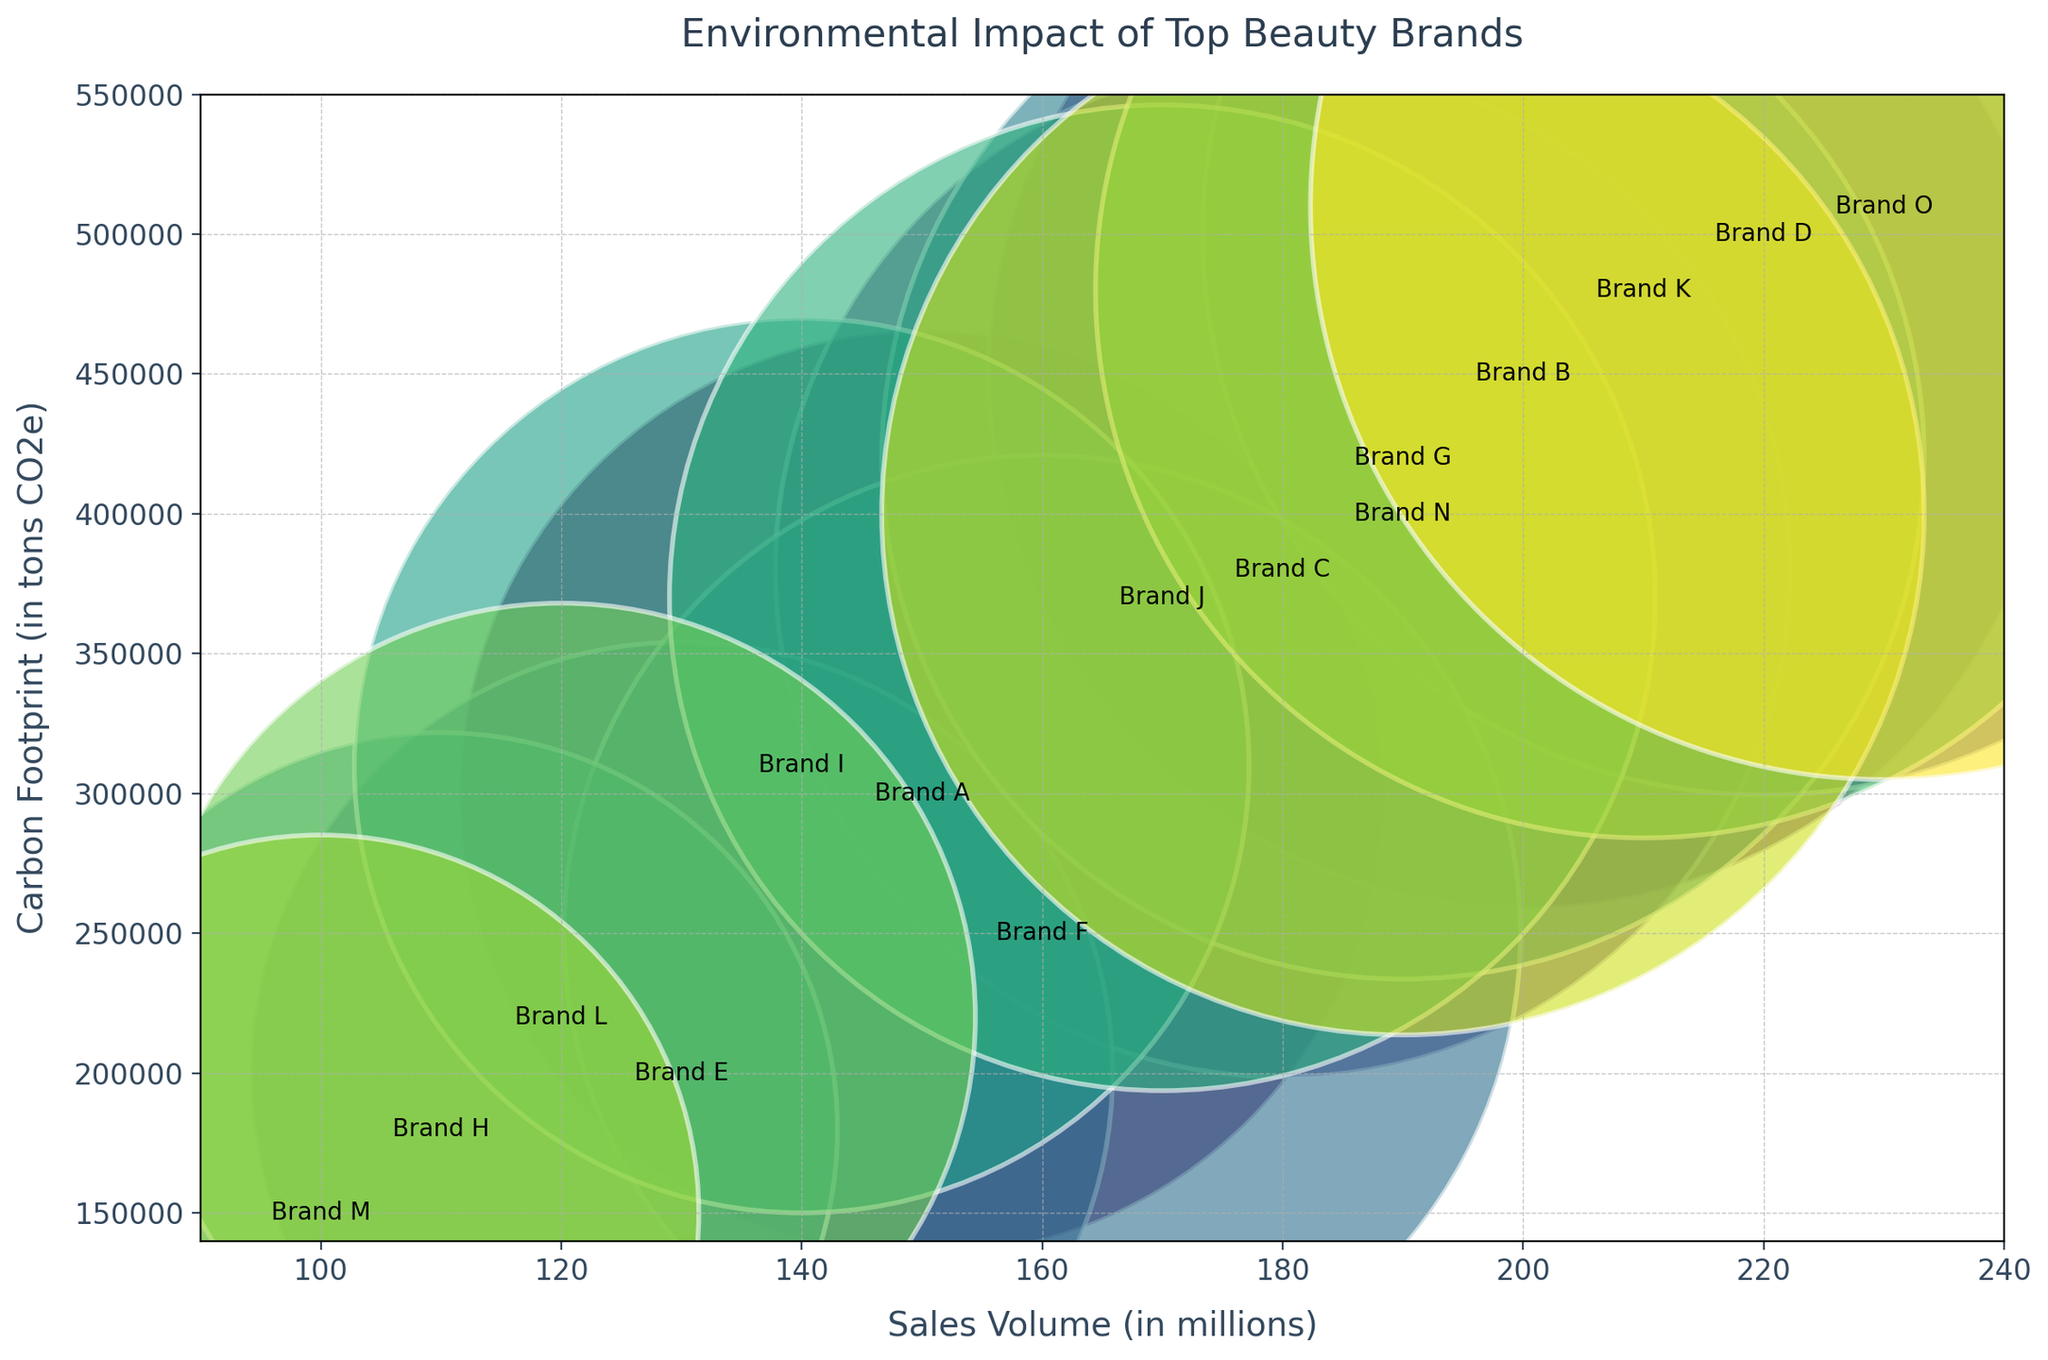Which brand has the highest sales volume? By looking at the x-axis, we can see the brand with the highest value on the sales volume scale.
Answer: Brand O Which brand has the smallest carbon footprint? By observing the y-axis, we can identify the brand with the lowest value on the carbon footprint scale.
Answer: Brand M Which brand has both a high sales volume and a high carbon footprint? By looking at brands situated in the top-right quadrant of the plot, we identify a brand with high values on both x and y axes.
Answer: Brand O How many brands have a carbon footprint greater than 400,000 tons CO2e? Counting the number of data points above the 400,000 mark on the y-axis gives us the answer.
Answer: 6 What is the average sales volume of brands with carbon footprints under 300,000 tons CO2e? Identify the brands with carbon footprints under 300,000, sum their sales volumes, and divide by the count of these brands: (150 + 130 + 160 + 140 + 120 + 100 + 110) / 7.
Answer: 130 million Which brand has a similar sales volume to Brand B but a lower carbon footprint? Find Brand B on the x-axis and look for another brand with a similar x-value but a lower y-value than Brand B.
Answer: Brand G What is the combined carbon footprint of the three brands with the highest sales volume? Identify the three highest x-values and sum their corresponding y-values: 510,000 (Brand O) + 500,000 (Brand D) + 480,000 (Brand K).
Answer: 1,490,000 tons CO2e Is there a brand with a sales volume between 150 and 160 million and a carbon footprint under 250,000 tons CO2e? If so, which brand? Find any data points within the x-axis range of 150 to 160 and check if their y-axis value is below 250,000.
Answer: Brand F Which brand has the largest bubble? The size of the bubbles corresponds to the sales volume as shown in the plot. Identify the largest bubble visually.
Answer: Brand O 